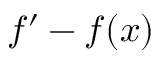Convert formula to latex. <formula><loc_0><loc_0><loc_500><loc_500>f ^ { \prime } - f ( x )</formula> 